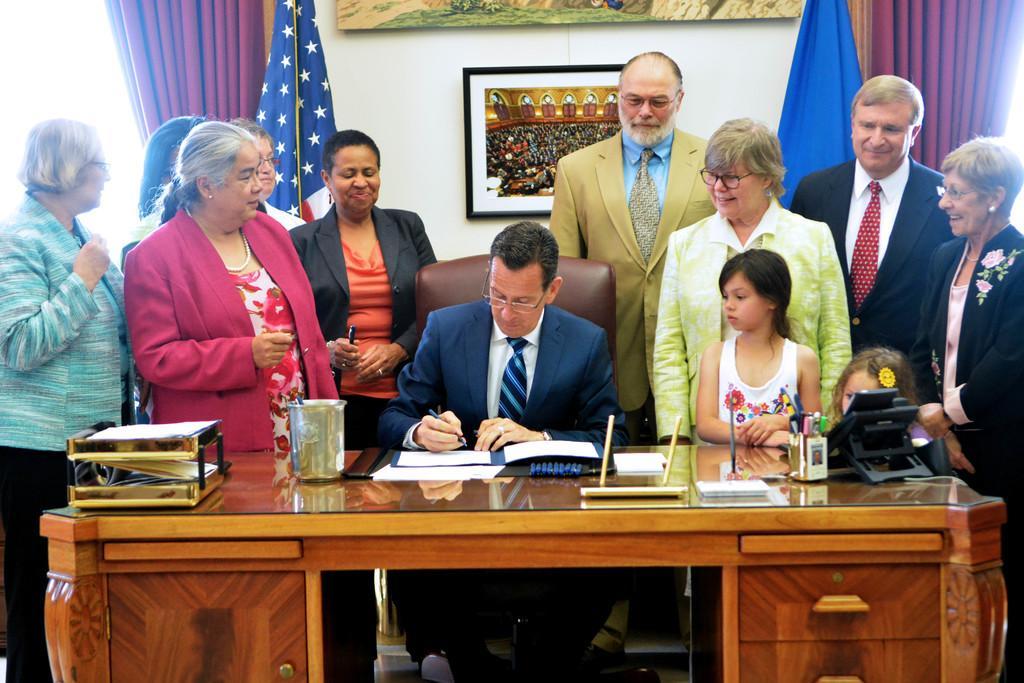In one or two sentences, can you explain what this image depicts? In this picture we can see a group of people standing, man holding a pen with his hand, sitting on a chair and in front of him we can see the table with papers, pen stand, some objects on it and in the background we can see flags, curtains and on the wall we can see frames. 